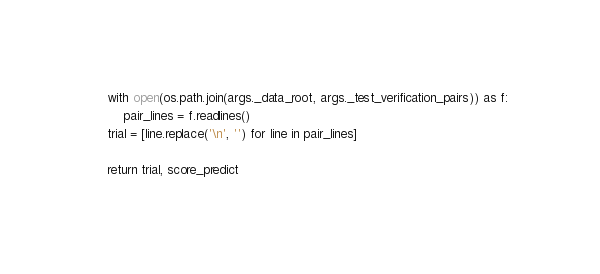<code> <loc_0><loc_0><loc_500><loc_500><_Python_>
    with open(os.path.join(args._data_root, args._test_verification_pairs)) as f:
        pair_lines = f.readlines()
    trial = [line.replace('\n', '') for line in pair_lines]

    return trial, score_predict

</code> 